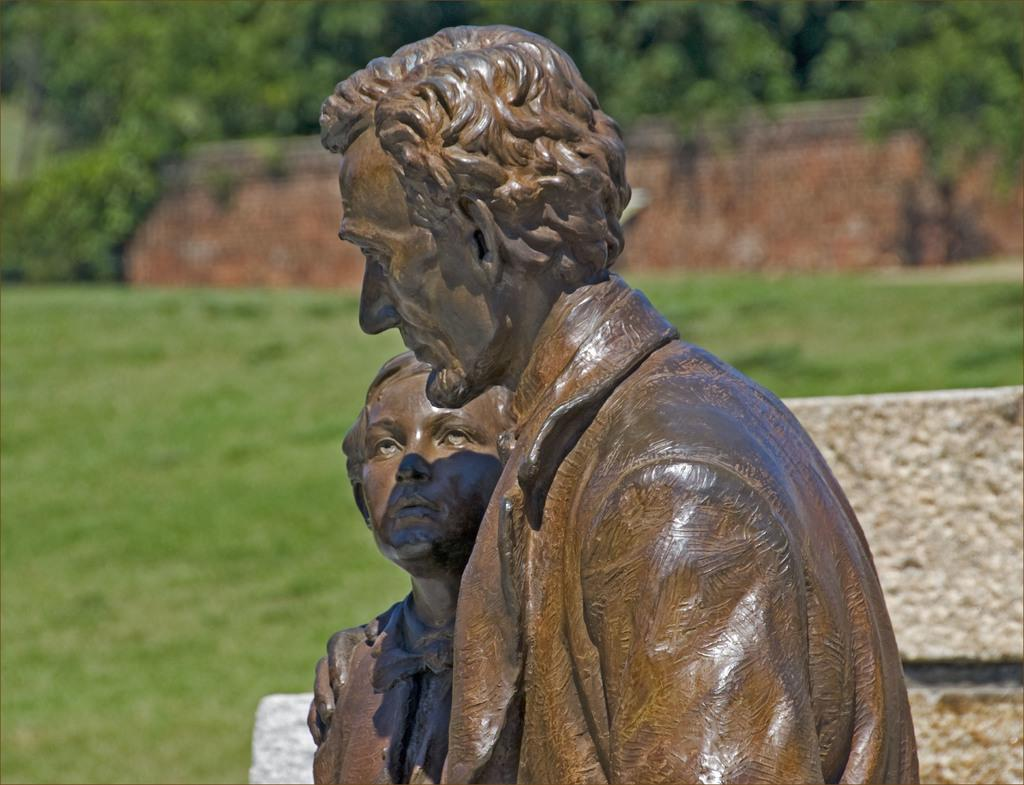What type of objects are depicted in the image? There are two wooden sculptures in the image. Can you describe the subjects of the sculptures? One sculpture is of an old man, and the other sculpture is of a small boy. What can be seen in the background of the image? There is a grass lawn and trees in the background of the image. What type of cup is the old man holding in the image? There is no cup present in the image; the old man is a wooden sculpture and does not hold any objects. 